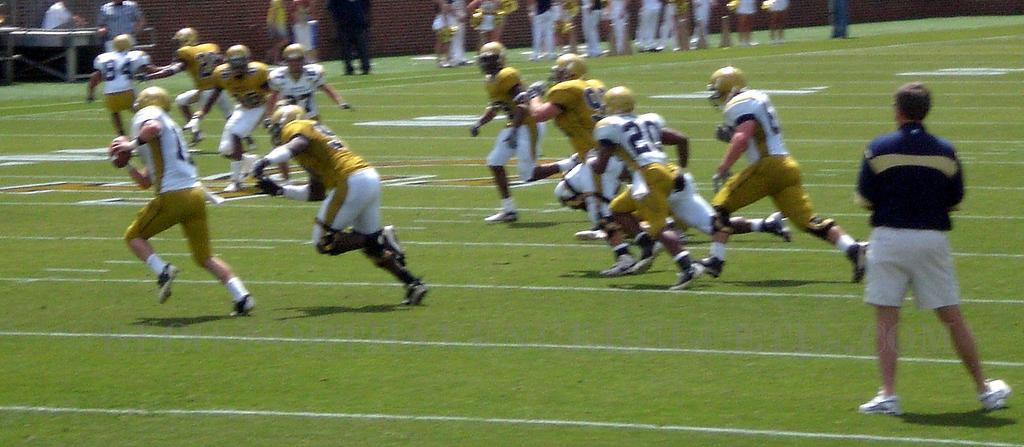Could you give a brief overview of what you see in this image? In this image we can see players playing in a ground. In the background there is a wall, table, persons and wall. 